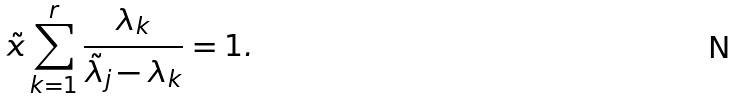<formula> <loc_0><loc_0><loc_500><loc_500>\tilde { x } \sum _ { k = 1 } ^ { r } \frac { \lambda _ { k } } { \tilde { \lambda } _ { j } - \lambda _ { k } } = 1 .</formula> 